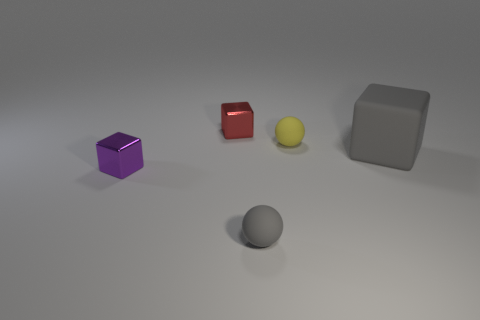Could you speculate on the size of these objects? Without explicit reference points, it's a bit challenging to ascertain the exact sizes, but judging by the soft shadows and the spacing, they could be small enough to fit in the palm of a hand or as large as household objects sitting on a table.  What could be the purpose of this arrangement of objects? This arrangement could be part of a visual study of form and color, an artistic composition, or even a setup for a computer graphics rendering test. It emphasizes the contrast between colors and shapes, as well as the interplay of light and texture. 